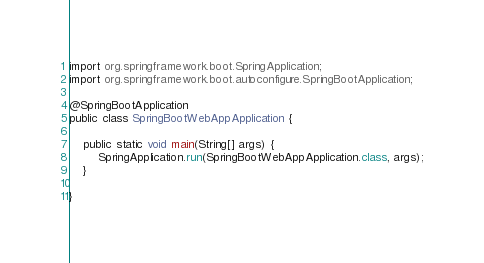Convert code to text. <code><loc_0><loc_0><loc_500><loc_500><_Java_>import org.springframework.boot.SpringApplication;
import org.springframework.boot.autoconfigure.SpringBootApplication;

@SpringBootApplication
public class SpringBootWebAppApplication {

	public static void main(String[] args) {
		SpringApplication.run(SpringBootWebAppApplication.class, args);
	}

}
</code> 